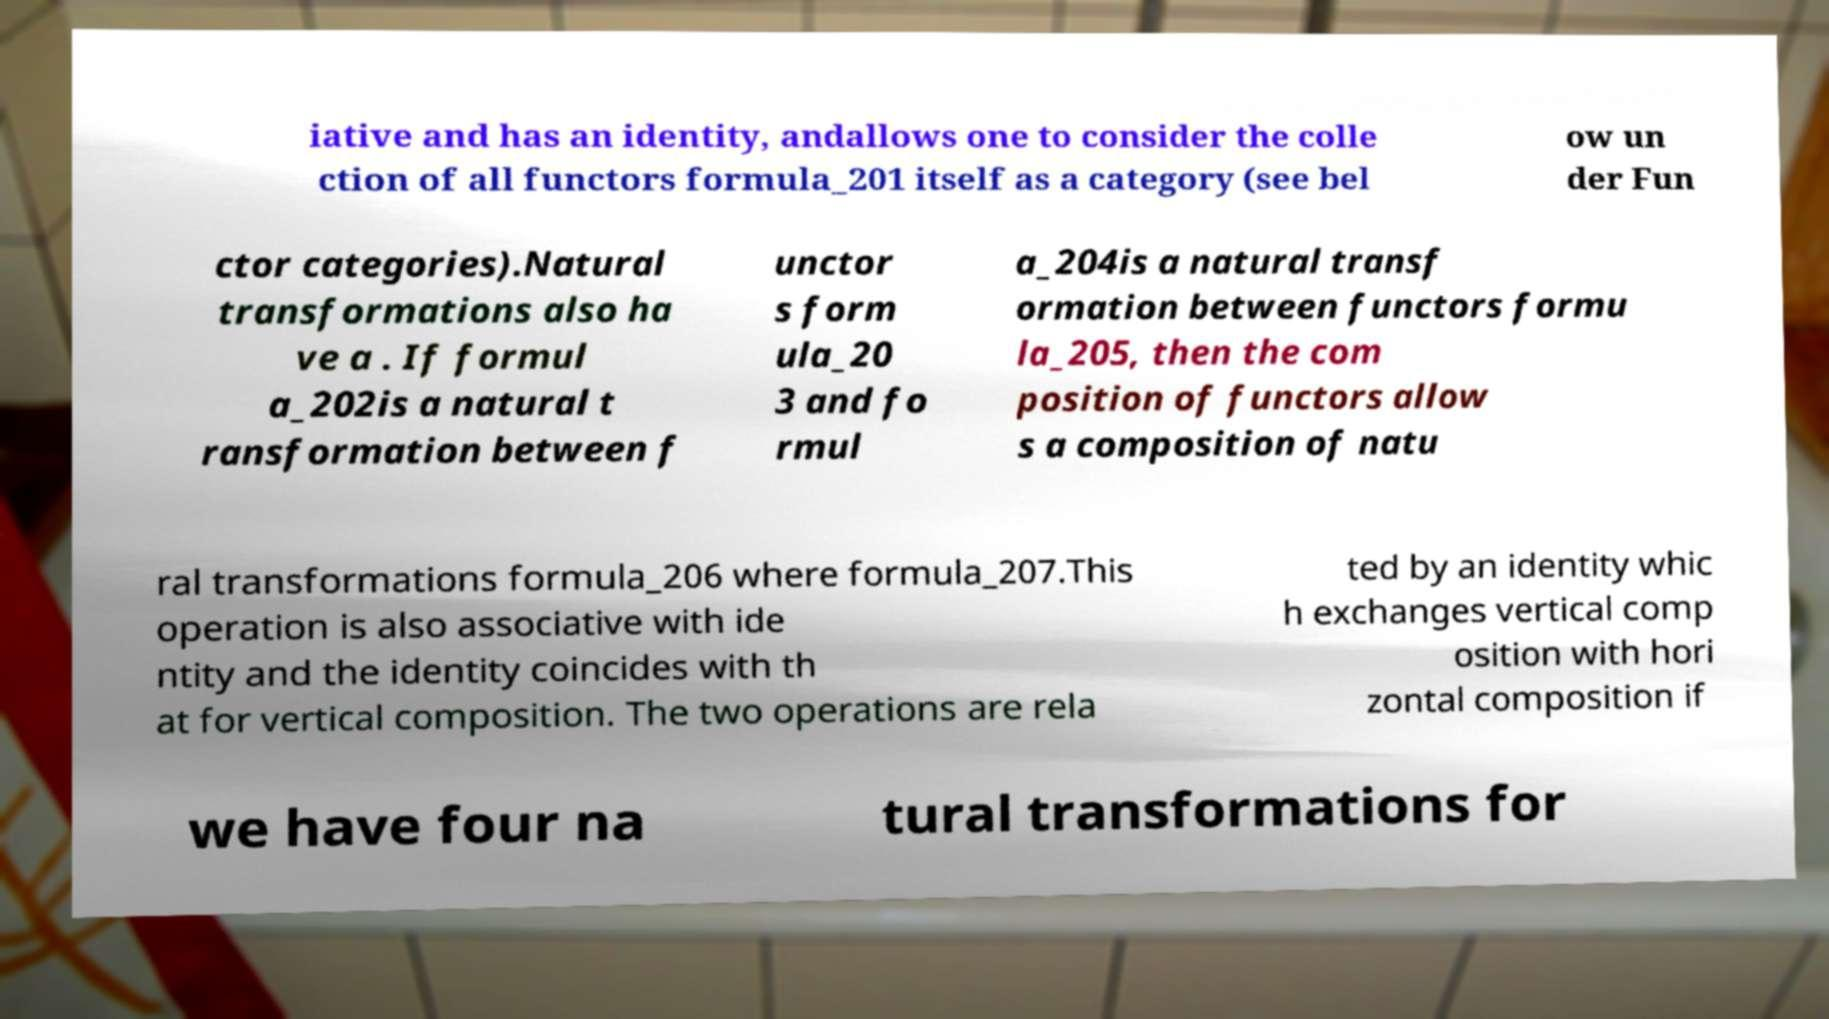Please identify and transcribe the text found in this image. iative and has an identity, andallows one to consider the colle ction of all functors formula_201 itself as a category (see bel ow un der Fun ctor categories).Natural transformations also ha ve a . If formul a_202is a natural t ransformation between f unctor s form ula_20 3 and fo rmul a_204is a natural transf ormation between functors formu la_205, then the com position of functors allow s a composition of natu ral transformations formula_206 where formula_207.This operation is also associative with ide ntity and the identity coincides with th at for vertical composition. The two operations are rela ted by an identity whic h exchanges vertical comp osition with hori zontal composition if we have four na tural transformations for 